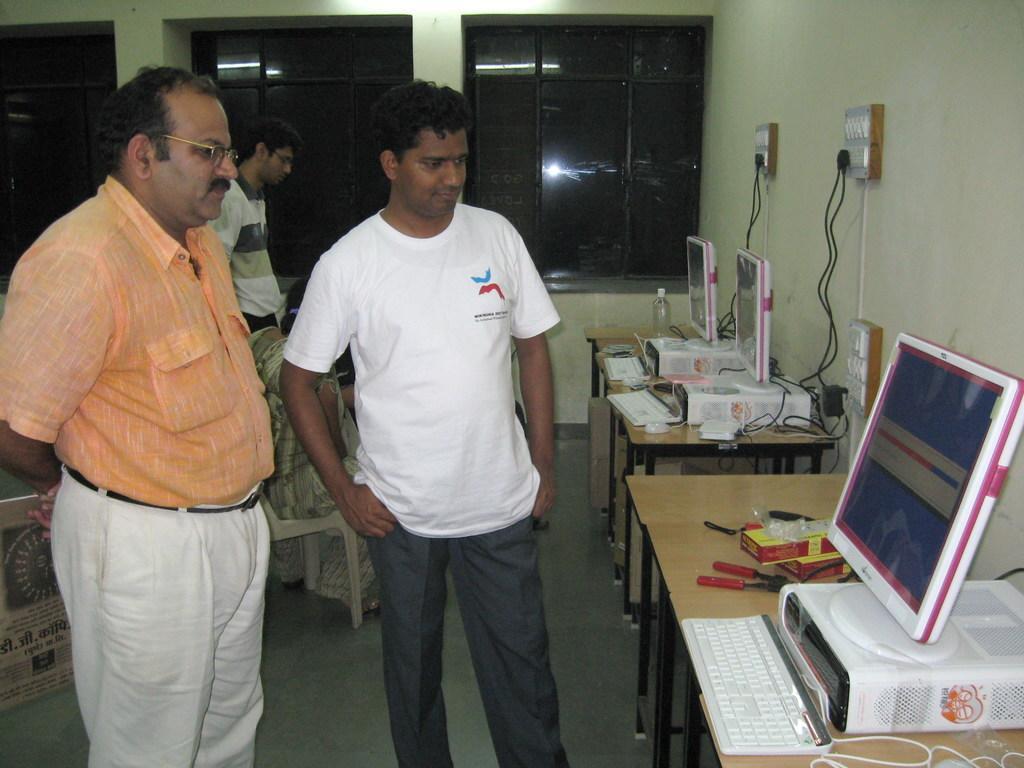In one or two sentences, can you explain what this image depicts? In this image, there are a few people. We can see some tables with objects like keyboards and screens. We can also see the wall with switchboards. We can see some glass windows. We can see the ground. 